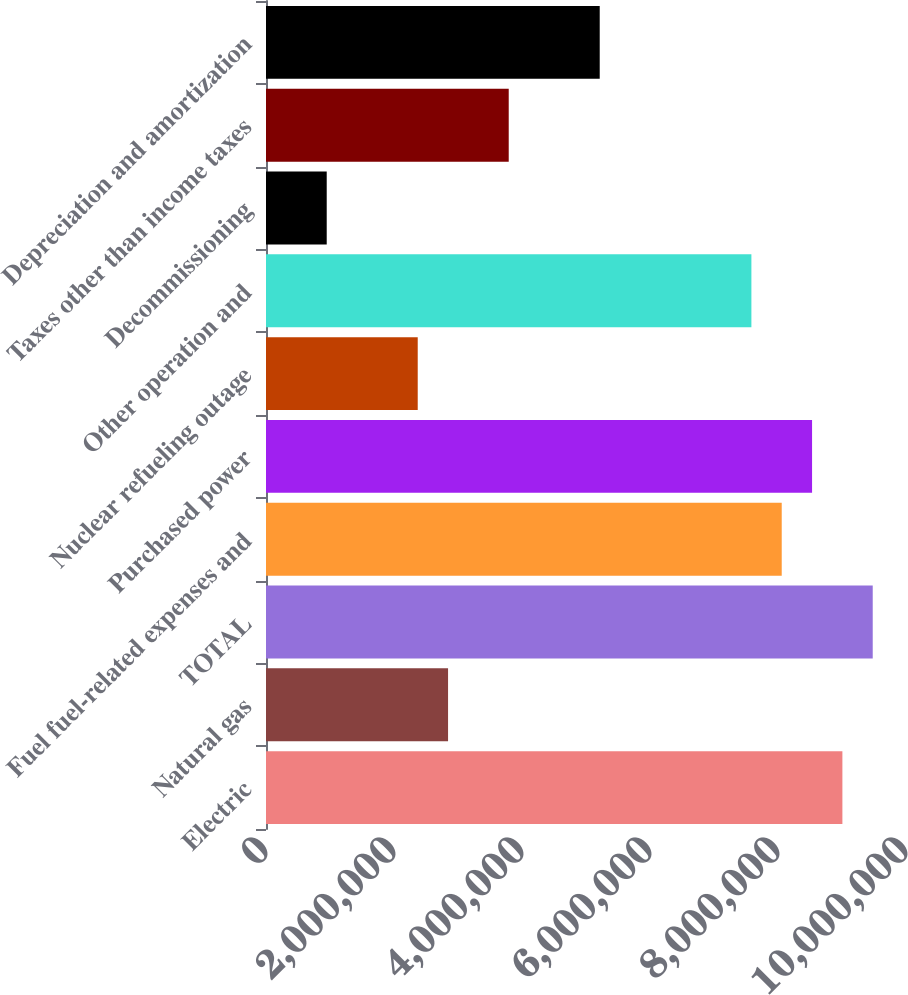<chart> <loc_0><loc_0><loc_500><loc_500><bar_chart><fcel>Electric<fcel>Natural gas<fcel>TOTAL<fcel>Fuel fuel-related expenses and<fcel>Purchased power<fcel>Nuclear refueling outage<fcel>Other operation and<fcel>Decommissioning<fcel>Taxes other than income taxes<fcel>Depreciation and amortization<nl><fcel>9.00619e+06<fcel>2.84464e+06<fcel>9.48016e+06<fcel>8.05826e+06<fcel>8.53223e+06<fcel>2.37068e+06<fcel>7.5843e+06<fcel>948781<fcel>3.79257e+06<fcel>5.21447e+06<nl></chart> 